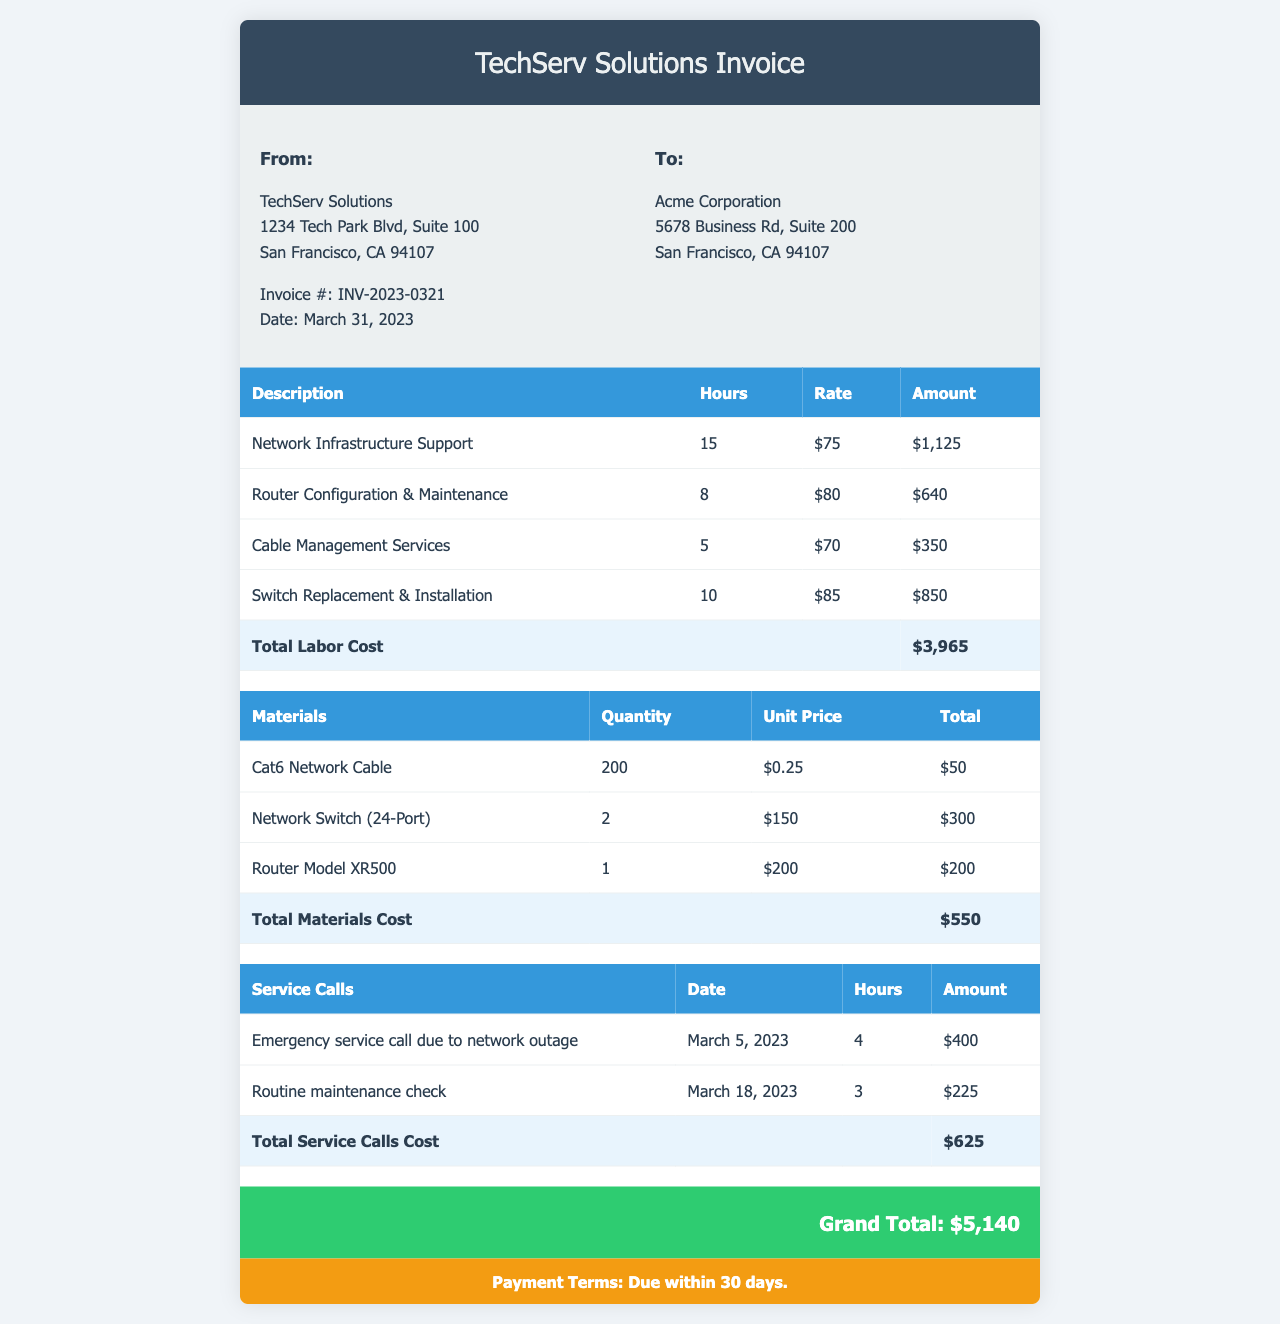What is the invoice number? The invoice number is listed in the document under the company details section.
Answer: INV-2023-0321 What is the date of the invoice? The date of the invoice is provided in the company details section of the document.
Answer: March 31, 2023 How many hours were billed for Network Infrastructure Support? The number of hours for Network Infrastructure Support is listed in the labor section of the invoice.
Answer: 15 What is the total labor cost? The total labor cost is calculated from the sum of the individual labor amounts listed in the document.
Answer: $3,965 What type of cable was listed in the materials? The materials section of the invoice includes specific types of items provided.
Answer: Cat6 Network Cable How much was charged for the emergency service call? The amount for the emergency service call is detailed in the service calls table of the document.
Answer: $400 What is the grand total of the invoice? The grand total is displayed prominently at the end of the invoice.
Answer: $5,140 How many units of the network switch were invoiced? The quantity of network switches is noted in the materials section of the invoice.
Answer: 2 What is the payment term for this invoice? The payment terms are included at the bottom of the document.
Answer: Due within 30 days 